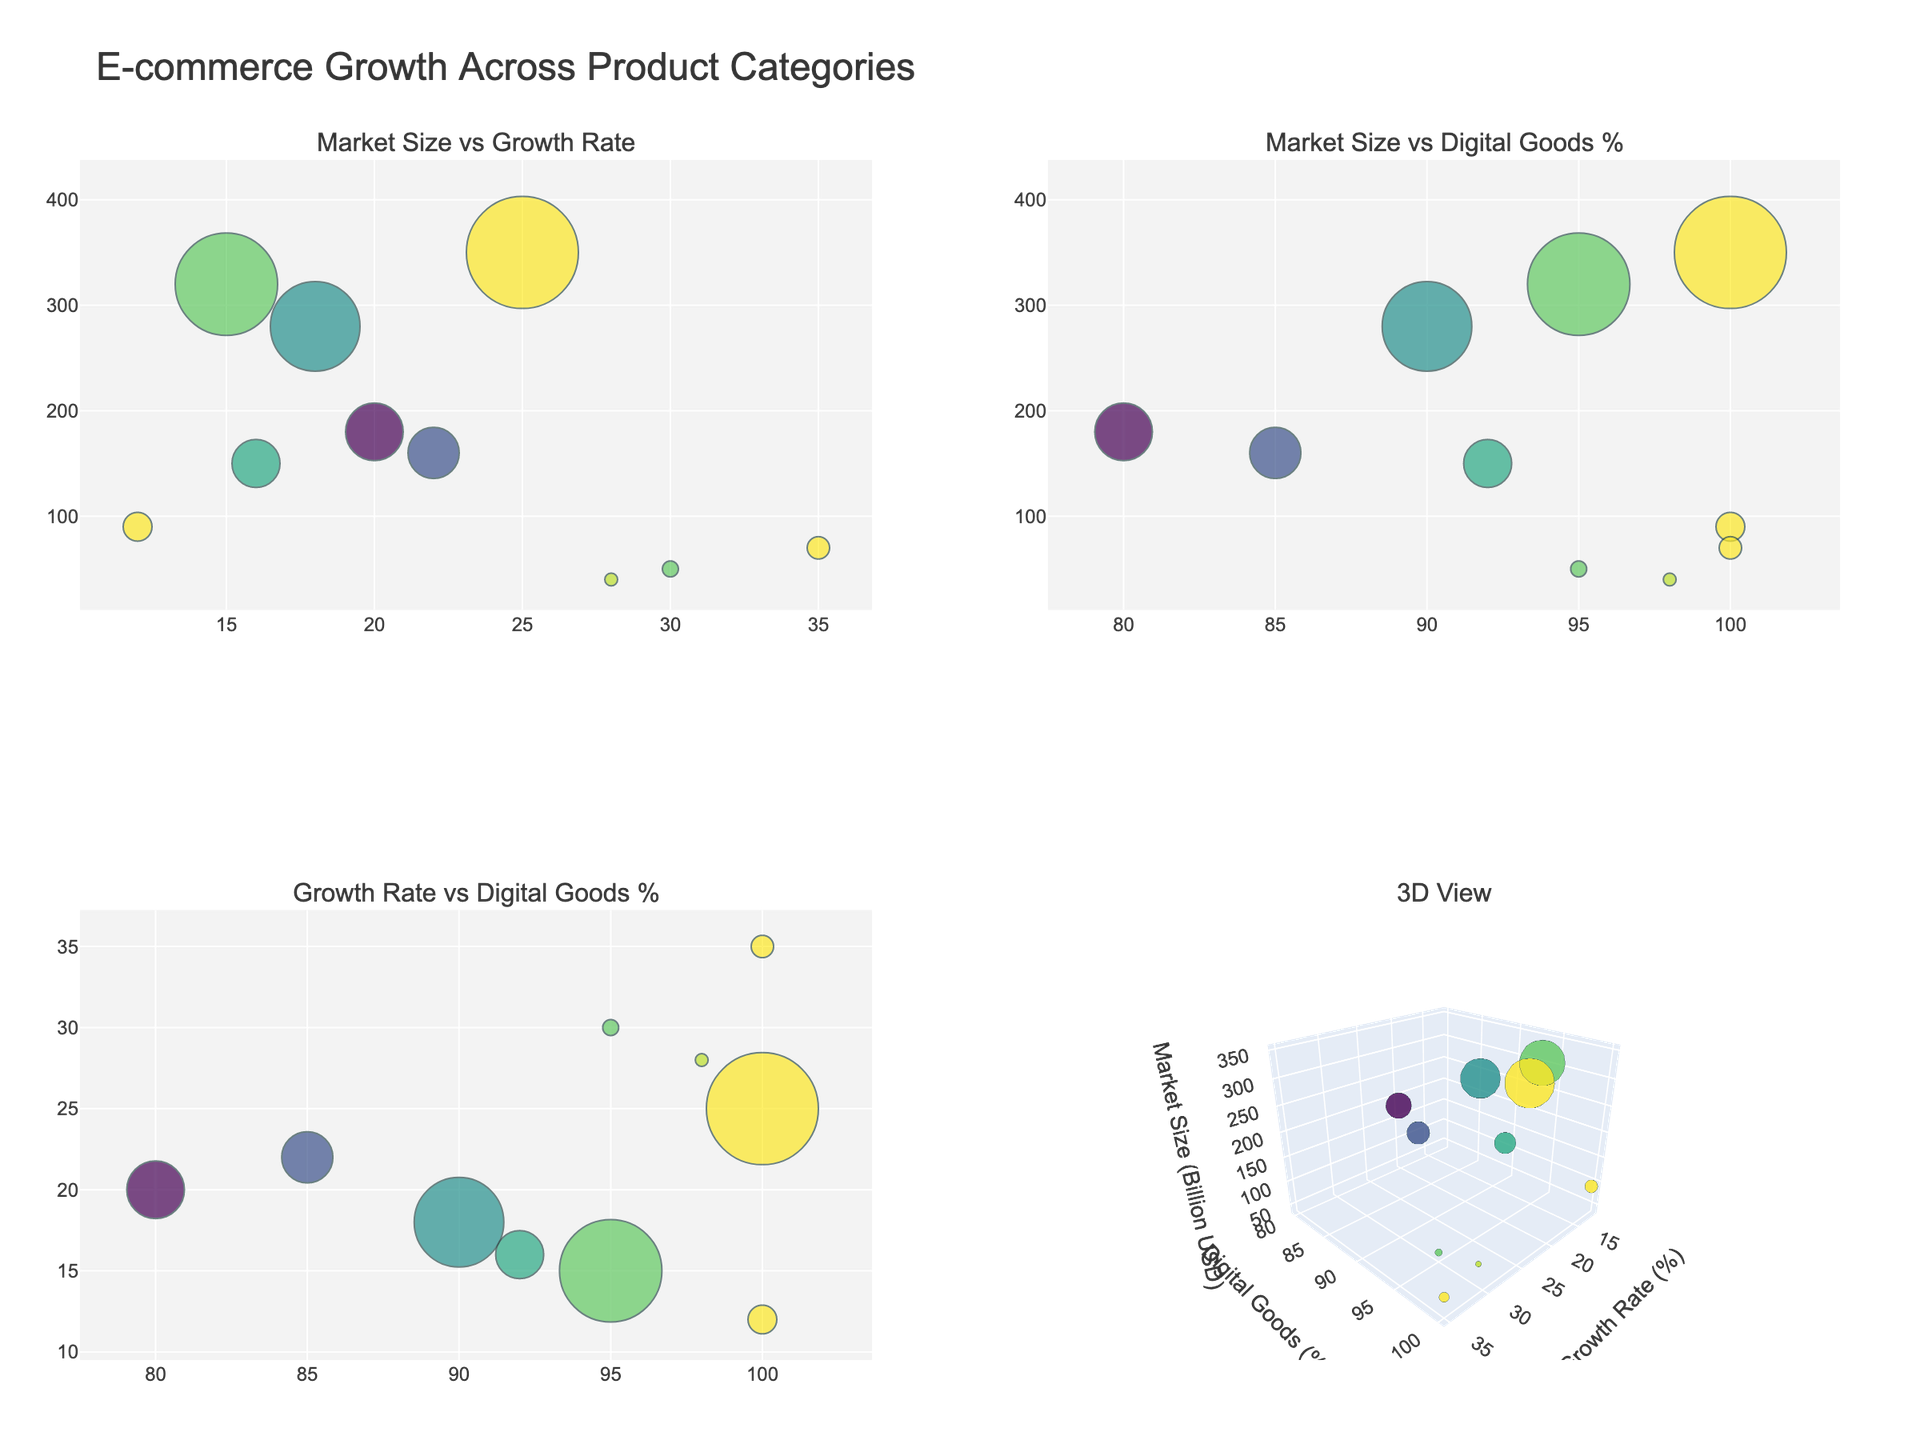What is the title of the figure? The title of the figure is prominently displayed at the top. It reads "E-commerce Growth Across Product Categories".
Answer: E-commerce Growth Across Product Categories Which category has the highest growth rate? Look at the bubble representing the category with the highest position on the Growth Rate (%) axis in any subplot that includes Growth Rate. The highest growth rate is 35%, corresponding to Cryptocurrency & NFTs.
Answer: Cryptocurrency & NFTs How many categories have a market size greater than 200 billion USD? Identify bubbles with sizes (representing market size) greater than 40 in any subplot. Since each unit corresponds to 5 billion USD, bubbles larger than 40 represent market sizes greater than 200 billion USD. There are 3 such categories: Software & Apps (320), Cloud Services (350), and Digital Media & Entertainment (280).
Answer: 3 What is the digital goods percentage for Online Education? Hover over or locate the bubble for Online Education on any subplot that includes Digital Goods Percentage. The digital goods percentage for Online Education is 85%.
Answer: 85% Which categories are represented in the 3D scatter plot? Hover over or look at the bubbles in the 3D scatter plot. Confirm that all categories mentioned in the data are represented.
Answer: All categories What is the relationship between Market Size and Digital Goods Percentage? Observe the subplot titled "Market Size vs Digital Goods %". There is no straightforward relationship; bubbles are scattered, indicating a lack of strong correlation.
Answer: No clear relationship Which category has the smallest market size, and what is its digital goods percentage? Locate the smallest bubble on any subplot. This bubble represents Digital Art & Design Assets with a market size of 40 billion USD and a digital goods percentage of 98%.
Answer: Digital Art & Design Assets, 98% Compare the growth rates of Online Education and Digital Marketing Services. Which one is higher and by how much percentage? Identify the bubbles for Online Education and Digital Marketing Services by their growth rates in the subplot “Market Size vs Growth Rate”. Online Education has a growth rate of 22%, while Digital Marketing Services has 20%. The difference is 22% - 20% = 2%.
Answer: Online Education, 2% What is the average market size for categories with a 100% digital goods percentage? Identify categories with 100% digital goods: E-books & Digital Publishing, Cloud Services, and Cryptocurrency & NFTs. Their market sizes are 90, 350, and 70 billion USD, respectively. Calculate their average: (90 + 350 + 70) / 3 = 170 billion USD.
Answer: 170 billion USD How does the market size of Cloud Services compare to Software & Apps? Compare the sizes of the bubbles representing Cloud Services and Software & Apps in any subplot. Cloud Services has a market size of 350 billion USD, while Software & Apps has 320 billion USD.
Answer: Cloud Services is larger 